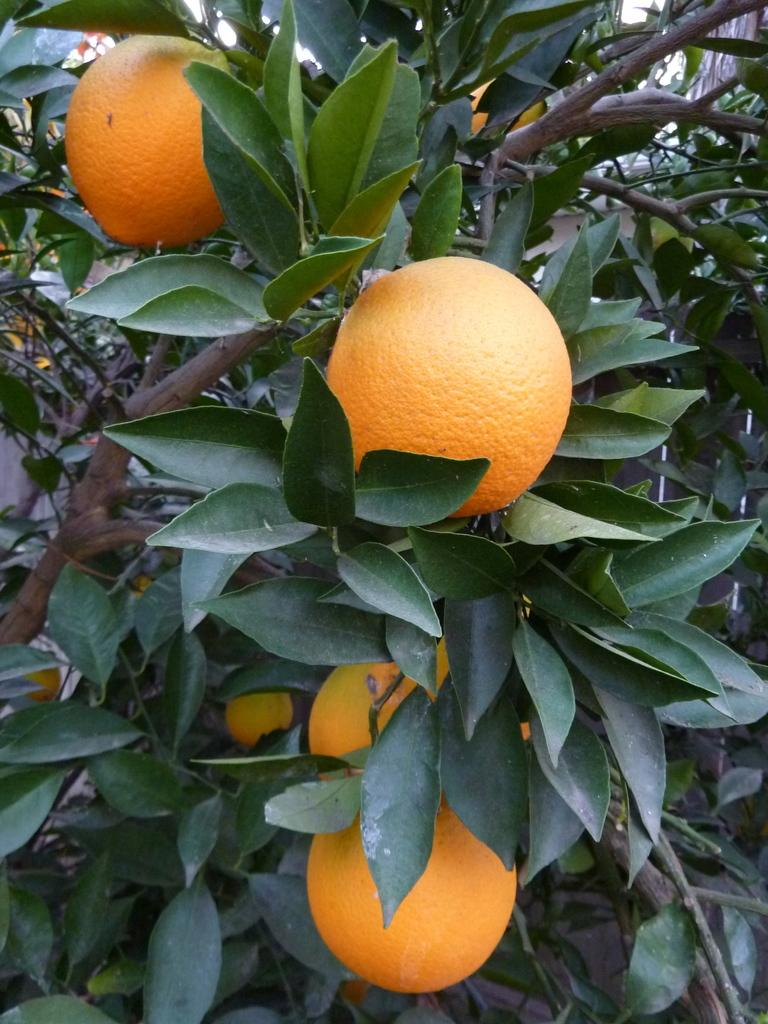What is the focus of the image? The image is a zoomed-in view. What can be seen hanging on the tree in the foreground? There are oranges hanging on the tree in the foreground. What color are the leaves visible in the image? The leaves visible in the image are green. What parts of the tree are present in the image? Branches and stems of the tree are visible in the image. How many bikes are visible in the image? There are no bikes present in the image; it features a tree with oranges and green leaves. Can you tell me how high the person is jumping in the image? There is no person or jumping activity depicted in the image; it is a close-up view of a tree with oranges and green leaves. 